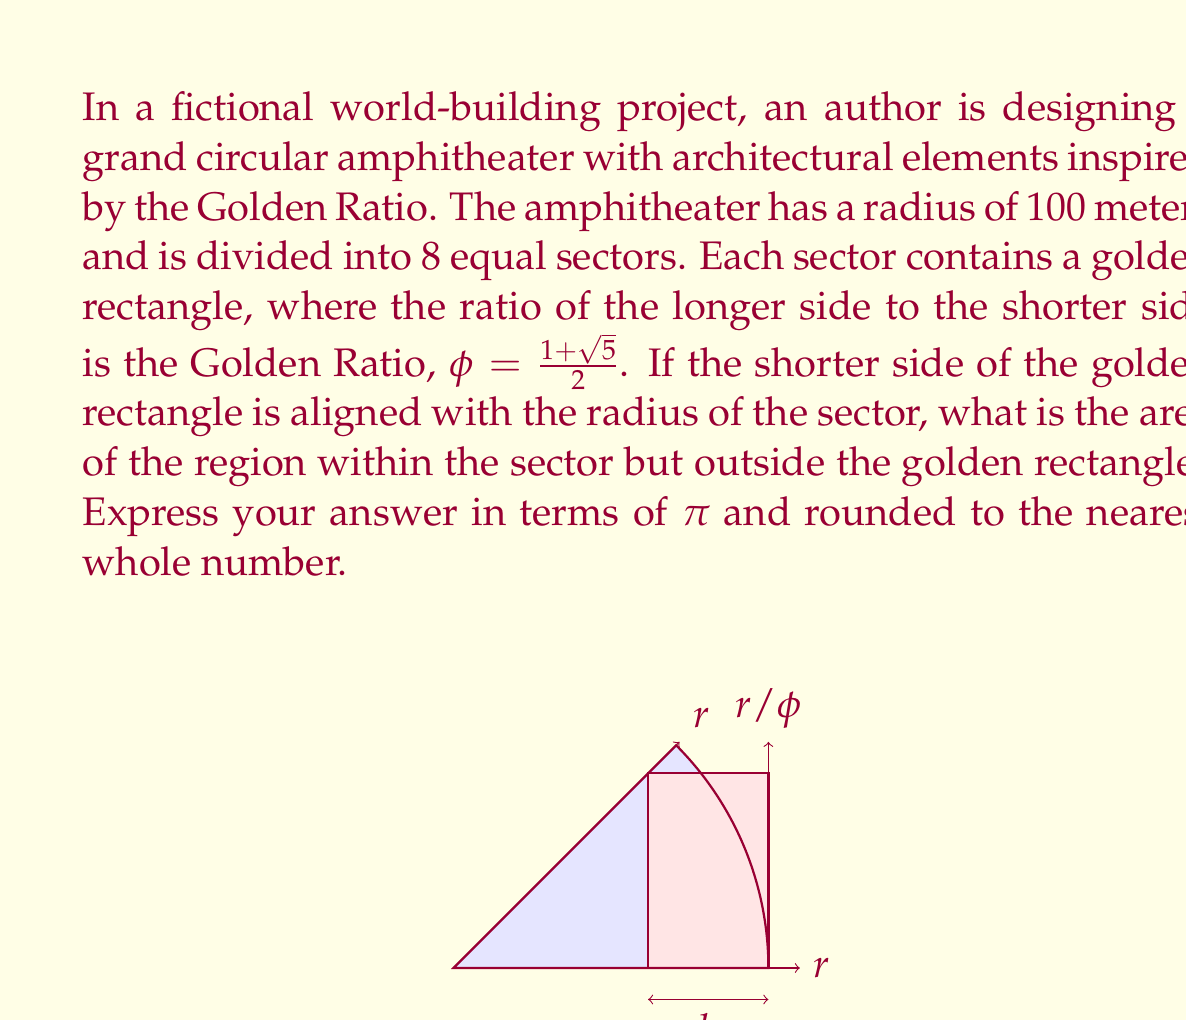Teach me how to tackle this problem. Let's approach this step-by-step:

1) The area of a sector with central angle $\theta$ in a circle of radius $r$ is given by:
   $$A_{sector} = \frac{1}{2}r^2\theta$$

2) For 8 equal sectors, $\theta = \frac{2\pi}{8} = \frac{\pi}{4}$

3) The area of the sector is:
   $$A_{sector} = \frac{1}{2}(100)^2\frac{\pi}{4} = 2500\pi \text{ m}^2$$

4) In a golden rectangle, if the shorter side is $h$, the longer side is $\phi h$. Here, $h$ is the radius of the sector, so $h = 100$ m.

5) The area of the golden rectangle is:
   $$A_{rectangle} = h \cdot \phi h = 100 \cdot 100\phi = 10000\phi \text{ m}^2$$

6) The Golden Ratio $\phi$ is:
   $$\phi = \frac{1+\sqrt{5}}{2} \approx 1.618034$$

7) Substituting this value:
   $$A_{rectangle} \approx 10000 \cdot 1.618034 = 16180.34 \text{ m}^2$$

8) The area we're looking for is the difference between the sector area and the rectangle area:
   $$A_{difference} = A_{sector} - A_{rectangle}$$
   $$A_{difference} = 2500\pi - 16180.34$$

9) Evaluating:
   $$A_{difference} \approx 7853.98 - 16180.34 = -8326.36 \text{ m}^2$$

10) The negative value indicates that the rectangle extends beyond the sector. The area we're interested in is the absolute value of this difference.
Answer: $8326\pi \text{ m}^2$ 